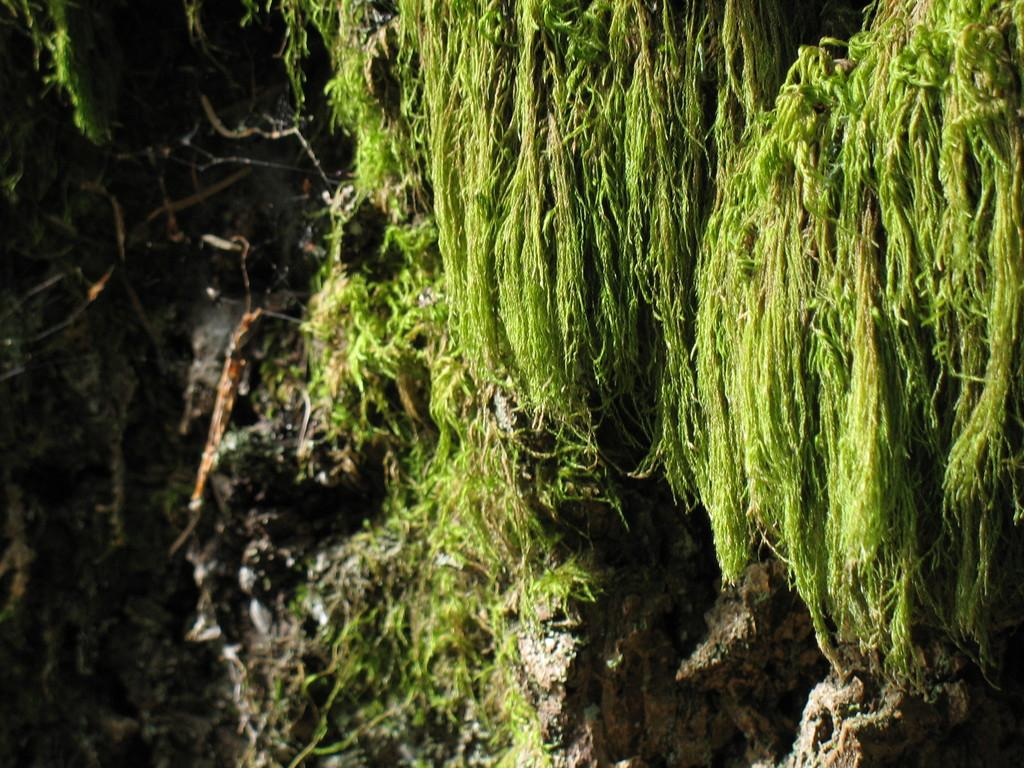What type of living organisms can be seen in the image? Plants can be seen in the image. What type of hands can be seen holding the plants in the image? There are no hands visible in the image, as it only features plants. 